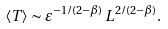Convert formula to latex. <formula><loc_0><loc_0><loc_500><loc_500>\langle T \rangle \sim \varepsilon ^ { - 1 / ( 2 - \beta ) } \, L ^ { 2 / ( 2 - \beta ) } .</formula> 